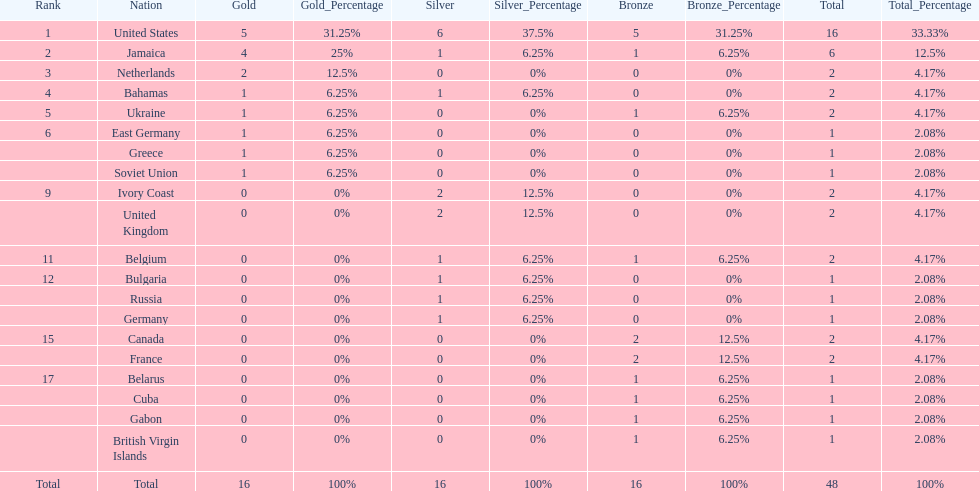How many nations received more medals than canada? 2. 